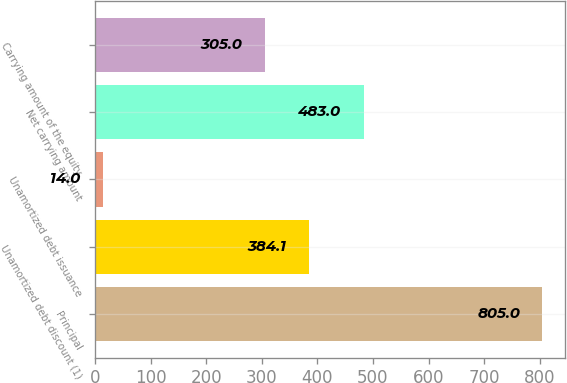Convert chart. <chart><loc_0><loc_0><loc_500><loc_500><bar_chart><fcel>Principal<fcel>Unamortized debt discount (1)<fcel>Unamortized debt issuance<fcel>Net carrying amount<fcel>Carrying amount of the equity<nl><fcel>805<fcel>384.1<fcel>14<fcel>483<fcel>305<nl></chart> 